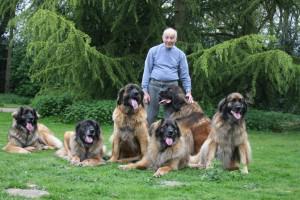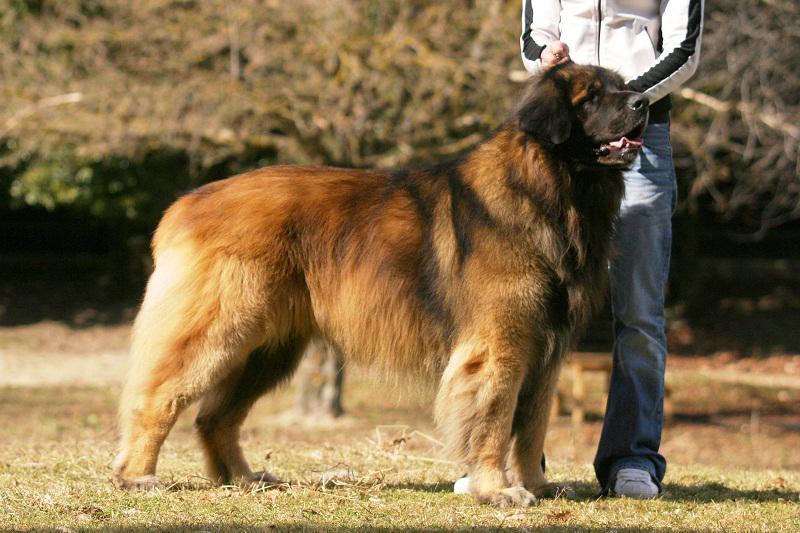The first image is the image on the left, the second image is the image on the right. Examine the images to the left and right. Is the description "At least one human is pictured with dogs." accurate? Answer yes or no. Yes. 